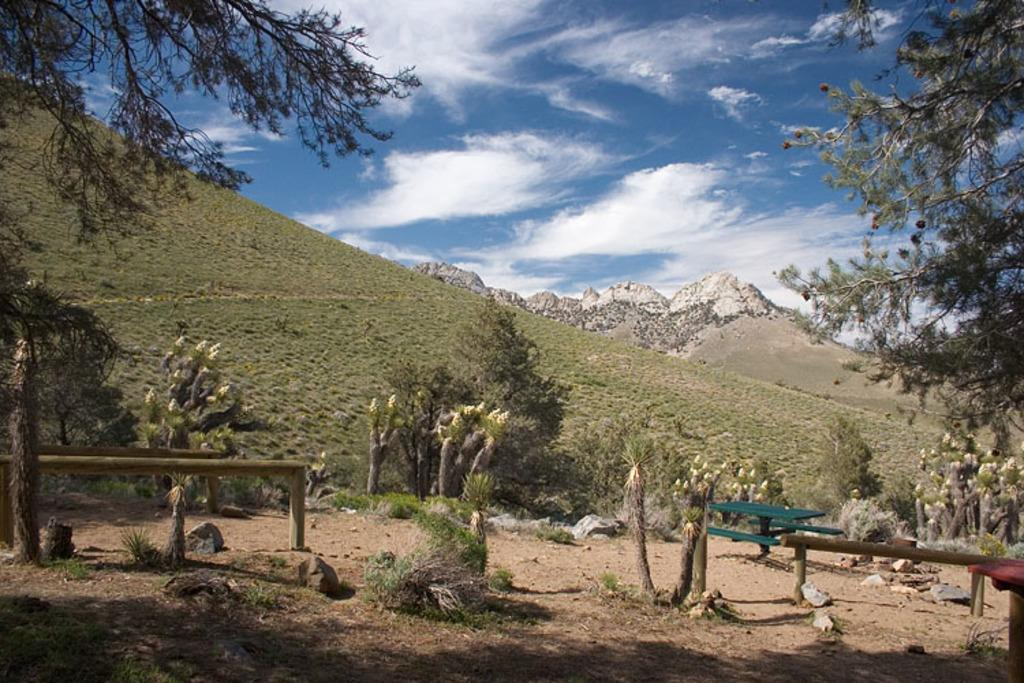What type of vegetation can be seen in the image? There are plants and trees in the image. What geographical feature is present in the image? There is a mountain in the image. What type of ground cover is visible in the image? There is grass visible in the image. What can be seen in the background of the image? The sky is visible in the background of the image. What is the condition of the sky in the image? There are clouds in the sky. Can you see any dinosaurs roaming around near the mountain in the image? No, there are no dinosaurs present in the image. Is there a table visible in the image? No, there is no table present in the image. 